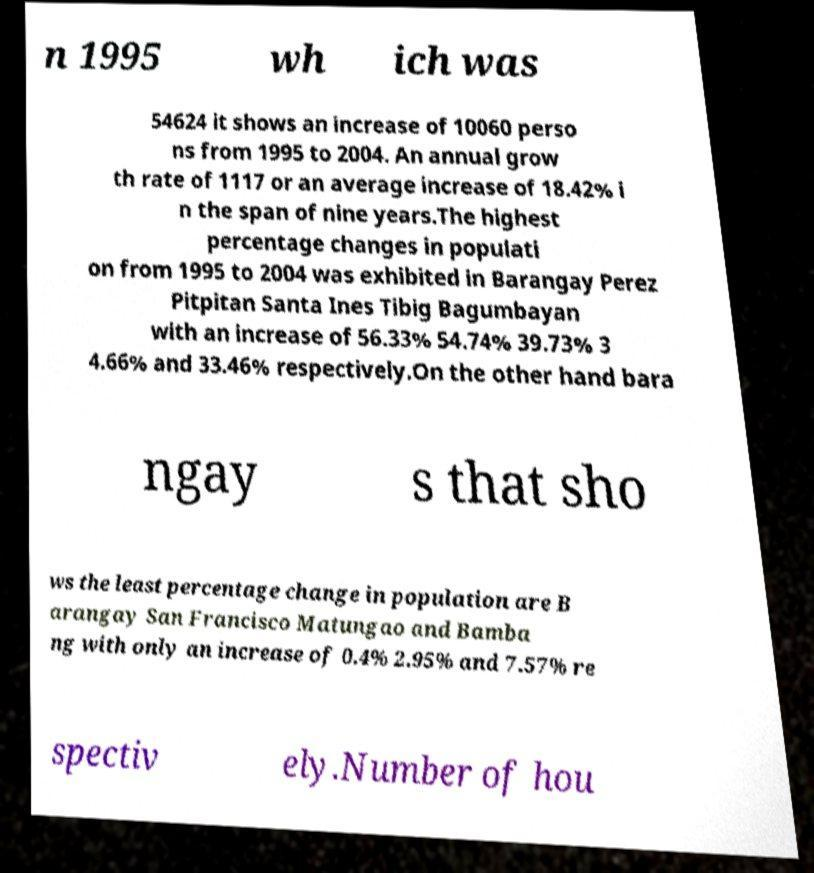What messages or text are displayed in this image? I need them in a readable, typed format. n 1995 wh ich was 54624 it shows an increase of 10060 perso ns from 1995 to 2004. An annual grow th rate of 1117 or an average increase of 18.42% i n the span of nine years.The highest percentage changes in populati on from 1995 to 2004 was exhibited in Barangay Perez Pitpitan Santa Ines Tibig Bagumbayan with an increase of 56.33% 54.74% 39.73% 3 4.66% and 33.46% respectively.On the other hand bara ngay s that sho ws the least percentage change in population are B arangay San Francisco Matungao and Bamba ng with only an increase of 0.4% 2.95% and 7.57% re spectiv ely.Number of hou 